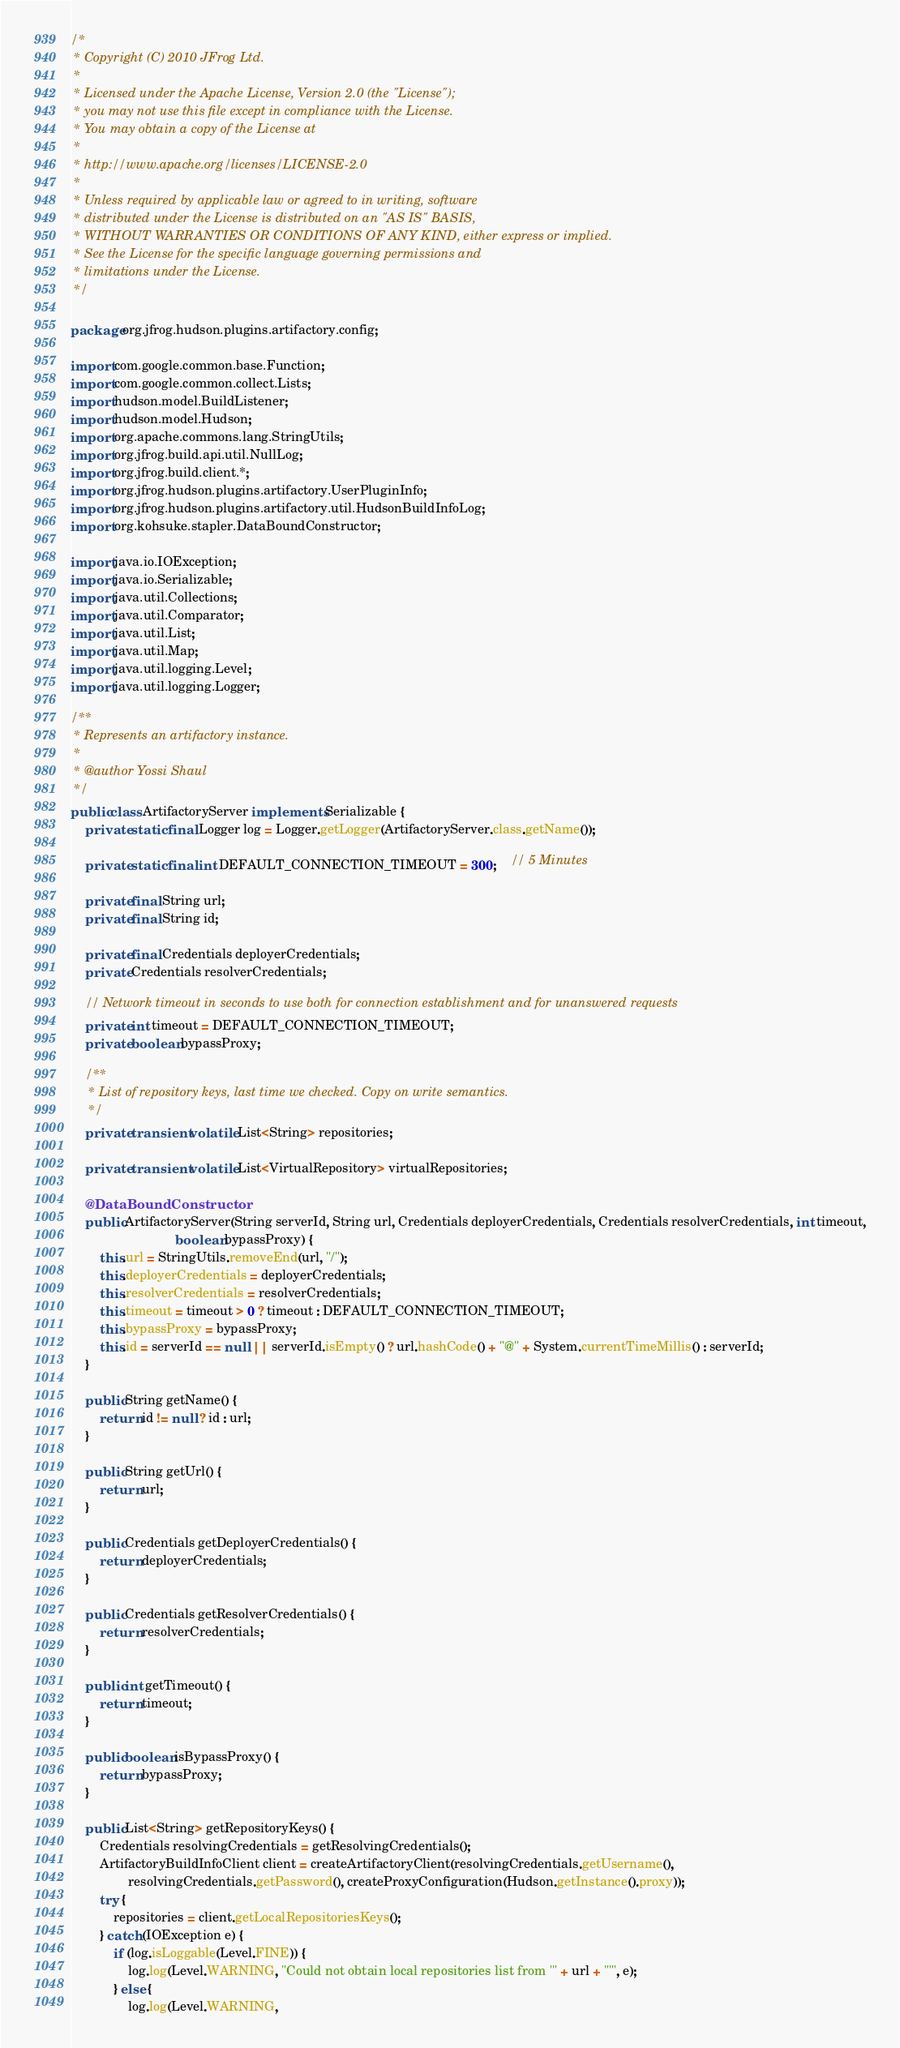<code> <loc_0><loc_0><loc_500><loc_500><_Java_>/*
 * Copyright (C) 2010 JFrog Ltd.
 *
 * Licensed under the Apache License, Version 2.0 (the "License");
 * you may not use this file except in compliance with the License.
 * You may obtain a copy of the License at
 *
 * http://www.apache.org/licenses/LICENSE-2.0
 *
 * Unless required by applicable law or agreed to in writing, software
 * distributed under the License is distributed on an "AS IS" BASIS,
 * WITHOUT WARRANTIES OR CONDITIONS OF ANY KIND, either express or implied.
 * See the License for the specific language governing permissions and
 * limitations under the License.
 */

package org.jfrog.hudson.plugins.artifactory.config;

import com.google.common.base.Function;
import com.google.common.collect.Lists;
import hudson.model.BuildListener;
import hudson.model.Hudson;
import org.apache.commons.lang.StringUtils;
import org.jfrog.build.api.util.NullLog;
import org.jfrog.build.client.*;
import org.jfrog.hudson.plugins.artifactory.UserPluginInfo;
import org.jfrog.hudson.plugins.artifactory.util.HudsonBuildInfoLog;
import org.kohsuke.stapler.DataBoundConstructor;

import java.io.IOException;
import java.io.Serializable;
import java.util.Collections;
import java.util.Comparator;
import java.util.List;
import java.util.Map;
import java.util.logging.Level;
import java.util.logging.Logger;

/**
 * Represents an artifactory instance.
 *
 * @author Yossi Shaul
 */
public class ArtifactoryServer implements Serializable {
    private static final Logger log = Logger.getLogger(ArtifactoryServer.class.getName());

    private static final int DEFAULT_CONNECTION_TIMEOUT = 300;    // 5 Minutes

    private final String url;
    private final String id;

    private final Credentials deployerCredentials;
    private Credentials resolverCredentials;

    // Network timeout in seconds to use both for connection establishment and for unanswered requests
    private int timeout = DEFAULT_CONNECTION_TIMEOUT;
    private boolean bypassProxy;

    /**
     * List of repository keys, last time we checked. Copy on write semantics.
     */
    private transient volatile List<String> repositories;

    private transient volatile List<VirtualRepository> virtualRepositories;

    @DataBoundConstructor
    public ArtifactoryServer(String serverId, String url, Credentials deployerCredentials, Credentials resolverCredentials, int timeout,
                             boolean bypassProxy) {
        this.url = StringUtils.removeEnd(url, "/");
        this.deployerCredentials = deployerCredentials;
        this.resolverCredentials = resolverCredentials;
        this.timeout = timeout > 0 ? timeout : DEFAULT_CONNECTION_TIMEOUT;
        this.bypassProxy = bypassProxy;
        this.id = serverId == null || serverId.isEmpty() ? url.hashCode() + "@" + System.currentTimeMillis() : serverId;
    }

    public String getName() {
        return id != null ? id : url;
    }

    public String getUrl() {
        return url;
    }

    public Credentials getDeployerCredentials() {
        return deployerCredentials;
    }

    public Credentials getResolverCredentials() {
        return resolverCredentials;
    }

    public int getTimeout() {
        return timeout;
    }

    public boolean isBypassProxy() {
        return bypassProxy;
    }

    public List<String> getRepositoryKeys() {
        Credentials resolvingCredentials = getResolvingCredentials();
        ArtifactoryBuildInfoClient client = createArtifactoryClient(resolvingCredentials.getUsername(),
                resolvingCredentials.getPassword(), createProxyConfiguration(Hudson.getInstance().proxy));
        try {
            repositories = client.getLocalRepositoriesKeys();
        } catch (IOException e) {
            if (log.isLoggable(Level.FINE)) {
                log.log(Level.WARNING, "Could not obtain local repositories list from '" + url + "'", e);
            } else {
                log.log(Level.WARNING,</code> 